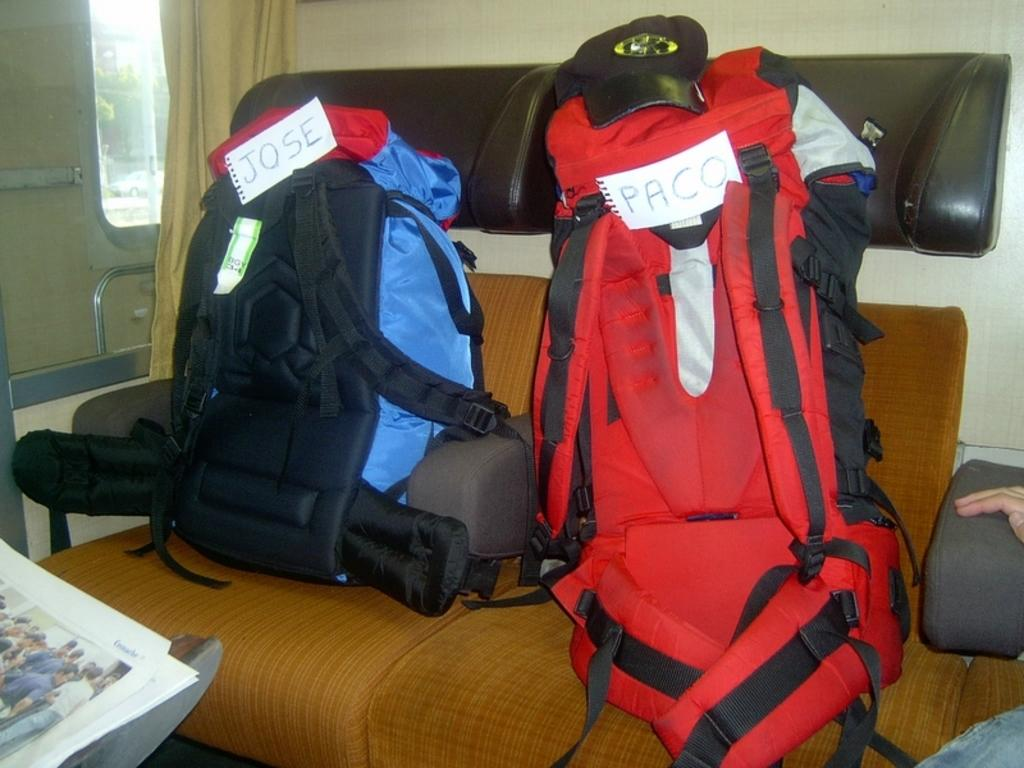<image>
Relay a brief, clear account of the picture shown. Jose owns the blue backpack and Paco owns the larger red backpack. 